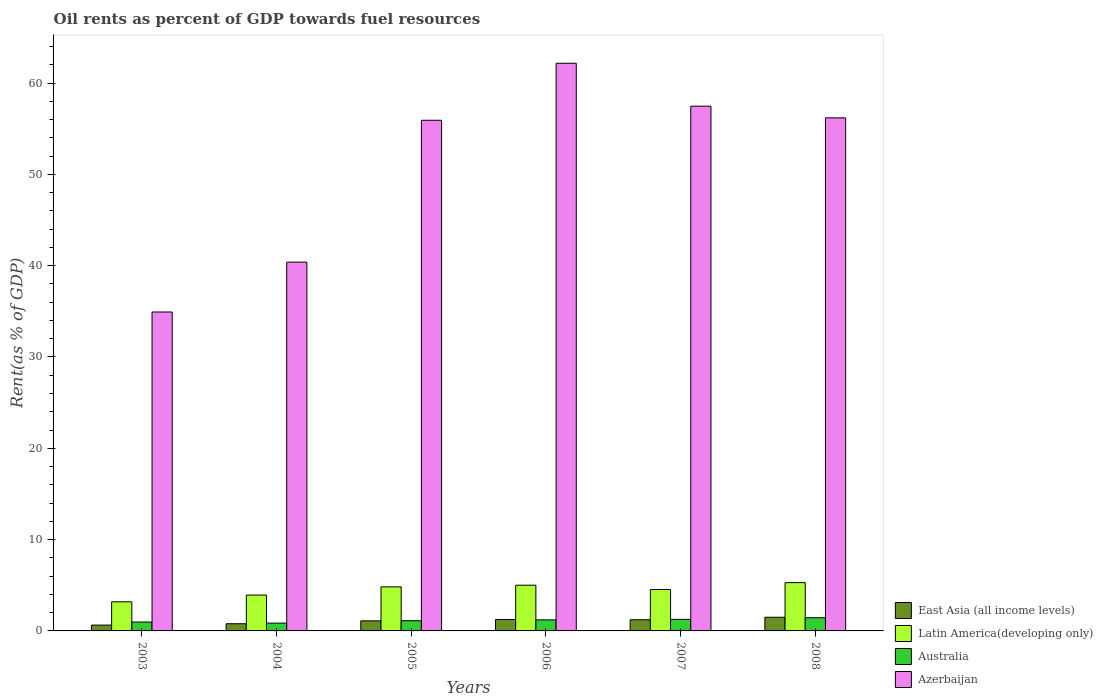How many groups of bars are there?
Provide a short and direct response. 6. Are the number of bars on each tick of the X-axis equal?
Offer a very short reply. Yes. How many bars are there on the 3rd tick from the right?
Keep it short and to the point. 4. In how many cases, is the number of bars for a given year not equal to the number of legend labels?
Provide a succinct answer. 0. What is the oil rent in Azerbaijan in 2005?
Make the answer very short. 55.92. Across all years, what is the maximum oil rent in Australia?
Make the answer very short. 1.45. Across all years, what is the minimum oil rent in Azerbaijan?
Keep it short and to the point. 34.93. In which year was the oil rent in East Asia (all income levels) maximum?
Provide a succinct answer. 2008. What is the total oil rent in East Asia (all income levels) in the graph?
Ensure brevity in your answer.  6.5. What is the difference between the oil rent in East Asia (all income levels) in 2003 and that in 2005?
Offer a very short reply. -0.46. What is the difference between the oil rent in Australia in 2005 and the oil rent in East Asia (all income levels) in 2006?
Provide a succinct answer. -0.13. What is the average oil rent in East Asia (all income levels) per year?
Give a very brief answer. 1.08. In the year 2007, what is the difference between the oil rent in Azerbaijan and oil rent in Latin America(developing only)?
Give a very brief answer. 52.93. What is the ratio of the oil rent in East Asia (all income levels) in 2006 to that in 2008?
Your answer should be very brief. 0.84. What is the difference between the highest and the second highest oil rent in Australia?
Offer a very short reply. 0.18. What is the difference between the highest and the lowest oil rent in Azerbaijan?
Keep it short and to the point. 27.24. Is it the case that in every year, the sum of the oil rent in Latin America(developing only) and oil rent in Australia is greater than the sum of oil rent in East Asia (all income levels) and oil rent in Azerbaijan?
Give a very brief answer. No. What does the 1st bar from the left in 2004 represents?
Provide a short and direct response. East Asia (all income levels). What does the 3rd bar from the right in 2008 represents?
Provide a short and direct response. Latin America(developing only). Does the graph contain grids?
Provide a succinct answer. No. How are the legend labels stacked?
Your response must be concise. Vertical. What is the title of the graph?
Offer a very short reply. Oil rents as percent of GDP towards fuel resources. What is the label or title of the Y-axis?
Ensure brevity in your answer.  Rent(as % of GDP). What is the Rent(as % of GDP) in East Asia (all income levels) in 2003?
Make the answer very short. 0.64. What is the Rent(as % of GDP) in Latin America(developing only) in 2003?
Make the answer very short. 3.19. What is the Rent(as % of GDP) of Australia in 2003?
Provide a succinct answer. 0.97. What is the Rent(as % of GDP) of Azerbaijan in 2003?
Your answer should be compact. 34.93. What is the Rent(as % of GDP) in East Asia (all income levels) in 2004?
Keep it short and to the point. 0.79. What is the Rent(as % of GDP) of Latin America(developing only) in 2004?
Give a very brief answer. 3.93. What is the Rent(as % of GDP) in Australia in 2004?
Make the answer very short. 0.85. What is the Rent(as % of GDP) in Azerbaijan in 2004?
Keep it short and to the point. 40.39. What is the Rent(as % of GDP) in East Asia (all income levels) in 2005?
Offer a terse response. 1.1. What is the Rent(as % of GDP) of Latin America(developing only) in 2005?
Provide a succinct answer. 4.83. What is the Rent(as % of GDP) of Australia in 2005?
Offer a terse response. 1.12. What is the Rent(as % of GDP) of Azerbaijan in 2005?
Your response must be concise. 55.92. What is the Rent(as % of GDP) in East Asia (all income levels) in 2006?
Provide a succinct answer. 1.25. What is the Rent(as % of GDP) of Latin America(developing only) in 2006?
Your answer should be compact. 5.01. What is the Rent(as % of GDP) of Australia in 2006?
Offer a very short reply. 1.21. What is the Rent(as % of GDP) in Azerbaijan in 2006?
Keep it short and to the point. 62.17. What is the Rent(as % of GDP) in East Asia (all income levels) in 2007?
Your response must be concise. 1.22. What is the Rent(as % of GDP) in Latin America(developing only) in 2007?
Offer a very short reply. 4.53. What is the Rent(as % of GDP) in Australia in 2007?
Offer a very short reply. 1.26. What is the Rent(as % of GDP) in Azerbaijan in 2007?
Offer a terse response. 57.47. What is the Rent(as % of GDP) of East Asia (all income levels) in 2008?
Offer a terse response. 1.5. What is the Rent(as % of GDP) in Latin America(developing only) in 2008?
Offer a very short reply. 5.29. What is the Rent(as % of GDP) of Australia in 2008?
Keep it short and to the point. 1.45. What is the Rent(as % of GDP) in Azerbaijan in 2008?
Your answer should be very brief. 56.19. Across all years, what is the maximum Rent(as % of GDP) in East Asia (all income levels)?
Make the answer very short. 1.5. Across all years, what is the maximum Rent(as % of GDP) in Latin America(developing only)?
Offer a terse response. 5.29. Across all years, what is the maximum Rent(as % of GDP) of Australia?
Offer a terse response. 1.45. Across all years, what is the maximum Rent(as % of GDP) of Azerbaijan?
Ensure brevity in your answer.  62.17. Across all years, what is the minimum Rent(as % of GDP) of East Asia (all income levels)?
Ensure brevity in your answer.  0.64. Across all years, what is the minimum Rent(as % of GDP) of Latin America(developing only)?
Your answer should be very brief. 3.19. Across all years, what is the minimum Rent(as % of GDP) in Australia?
Your answer should be very brief. 0.85. Across all years, what is the minimum Rent(as % of GDP) in Azerbaijan?
Offer a terse response. 34.93. What is the total Rent(as % of GDP) in East Asia (all income levels) in the graph?
Give a very brief answer. 6.5. What is the total Rent(as % of GDP) of Latin America(developing only) in the graph?
Your response must be concise. 26.77. What is the total Rent(as % of GDP) of Australia in the graph?
Offer a very short reply. 6.87. What is the total Rent(as % of GDP) in Azerbaijan in the graph?
Keep it short and to the point. 307.05. What is the difference between the Rent(as % of GDP) in East Asia (all income levels) in 2003 and that in 2004?
Give a very brief answer. -0.15. What is the difference between the Rent(as % of GDP) of Latin America(developing only) in 2003 and that in 2004?
Give a very brief answer. -0.74. What is the difference between the Rent(as % of GDP) of Australia in 2003 and that in 2004?
Keep it short and to the point. 0.12. What is the difference between the Rent(as % of GDP) of Azerbaijan in 2003 and that in 2004?
Your answer should be compact. -5.46. What is the difference between the Rent(as % of GDP) of East Asia (all income levels) in 2003 and that in 2005?
Provide a succinct answer. -0.46. What is the difference between the Rent(as % of GDP) of Latin America(developing only) in 2003 and that in 2005?
Your response must be concise. -1.64. What is the difference between the Rent(as % of GDP) in Australia in 2003 and that in 2005?
Ensure brevity in your answer.  -0.15. What is the difference between the Rent(as % of GDP) in Azerbaijan in 2003 and that in 2005?
Provide a succinct answer. -21. What is the difference between the Rent(as % of GDP) in East Asia (all income levels) in 2003 and that in 2006?
Your answer should be compact. -0.61. What is the difference between the Rent(as % of GDP) in Latin America(developing only) in 2003 and that in 2006?
Provide a short and direct response. -1.82. What is the difference between the Rent(as % of GDP) of Australia in 2003 and that in 2006?
Your answer should be compact. -0.24. What is the difference between the Rent(as % of GDP) of Azerbaijan in 2003 and that in 2006?
Keep it short and to the point. -27.24. What is the difference between the Rent(as % of GDP) of East Asia (all income levels) in 2003 and that in 2007?
Offer a very short reply. -0.59. What is the difference between the Rent(as % of GDP) of Latin America(developing only) in 2003 and that in 2007?
Ensure brevity in your answer.  -1.34. What is the difference between the Rent(as % of GDP) in Australia in 2003 and that in 2007?
Your response must be concise. -0.29. What is the difference between the Rent(as % of GDP) in Azerbaijan in 2003 and that in 2007?
Give a very brief answer. -22.54. What is the difference between the Rent(as % of GDP) of East Asia (all income levels) in 2003 and that in 2008?
Offer a very short reply. -0.86. What is the difference between the Rent(as % of GDP) of Latin America(developing only) in 2003 and that in 2008?
Provide a succinct answer. -2.1. What is the difference between the Rent(as % of GDP) of Australia in 2003 and that in 2008?
Keep it short and to the point. -0.47. What is the difference between the Rent(as % of GDP) in Azerbaijan in 2003 and that in 2008?
Offer a very short reply. -21.26. What is the difference between the Rent(as % of GDP) of East Asia (all income levels) in 2004 and that in 2005?
Offer a very short reply. -0.31. What is the difference between the Rent(as % of GDP) of Latin America(developing only) in 2004 and that in 2005?
Your answer should be very brief. -0.9. What is the difference between the Rent(as % of GDP) of Australia in 2004 and that in 2005?
Give a very brief answer. -0.26. What is the difference between the Rent(as % of GDP) of Azerbaijan in 2004 and that in 2005?
Your response must be concise. -15.53. What is the difference between the Rent(as % of GDP) in East Asia (all income levels) in 2004 and that in 2006?
Your answer should be compact. -0.46. What is the difference between the Rent(as % of GDP) of Latin America(developing only) in 2004 and that in 2006?
Offer a very short reply. -1.08. What is the difference between the Rent(as % of GDP) of Australia in 2004 and that in 2006?
Make the answer very short. -0.36. What is the difference between the Rent(as % of GDP) in Azerbaijan in 2004 and that in 2006?
Provide a succinct answer. -21.78. What is the difference between the Rent(as % of GDP) of East Asia (all income levels) in 2004 and that in 2007?
Ensure brevity in your answer.  -0.44. What is the difference between the Rent(as % of GDP) of Latin America(developing only) in 2004 and that in 2007?
Provide a succinct answer. -0.61. What is the difference between the Rent(as % of GDP) of Australia in 2004 and that in 2007?
Keep it short and to the point. -0.41. What is the difference between the Rent(as % of GDP) of Azerbaijan in 2004 and that in 2007?
Ensure brevity in your answer.  -17.08. What is the difference between the Rent(as % of GDP) of East Asia (all income levels) in 2004 and that in 2008?
Offer a terse response. -0.71. What is the difference between the Rent(as % of GDP) in Latin America(developing only) in 2004 and that in 2008?
Provide a succinct answer. -1.36. What is the difference between the Rent(as % of GDP) of Australia in 2004 and that in 2008?
Offer a terse response. -0.59. What is the difference between the Rent(as % of GDP) in Azerbaijan in 2004 and that in 2008?
Your answer should be compact. -15.8. What is the difference between the Rent(as % of GDP) in East Asia (all income levels) in 2005 and that in 2006?
Give a very brief answer. -0.15. What is the difference between the Rent(as % of GDP) in Latin America(developing only) in 2005 and that in 2006?
Ensure brevity in your answer.  -0.18. What is the difference between the Rent(as % of GDP) of Australia in 2005 and that in 2006?
Give a very brief answer. -0.09. What is the difference between the Rent(as % of GDP) in Azerbaijan in 2005 and that in 2006?
Your answer should be very brief. -6.24. What is the difference between the Rent(as % of GDP) of East Asia (all income levels) in 2005 and that in 2007?
Your response must be concise. -0.12. What is the difference between the Rent(as % of GDP) of Latin America(developing only) in 2005 and that in 2007?
Give a very brief answer. 0.29. What is the difference between the Rent(as % of GDP) of Australia in 2005 and that in 2007?
Offer a terse response. -0.15. What is the difference between the Rent(as % of GDP) in Azerbaijan in 2005 and that in 2007?
Your response must be concise. -1.54. What is the difference between the Rent(as % of GDP) in East Asia (all income levels) in 2005 and that in 2008?
Keep it short and to the point. -0.39. What is the difference between the Rent(as % of GDP) of Latin America(developing only) in 2005 and that in 2008?
Offer a very short reply. -0.46. What is the difference between the Rent(as % of GDP) in Australia in 2005 and that in 2008?
Offer a very short reply. -0.33. What is the difference between the Rent(as % of GDP) in Azerbaijan in 2005 and that in 2008?
Keep it short and to the point. -0.26. What is the difference between the Rent(as % of GDP) in East Asia (all income levels) in 2006 and that in 2007?
Your response must be concise. 0.03. What is the difference between the Rent(as % of GDP) in Latin America(developing only) in 2006 and that in 2007?
Your answer should be compact. 0.47. What is the difference between the Rent(as % of GDP) of Australia in 2006 and that in 2007?
Your answer should be compact. -0.05. What is the difference between the Rent(as % of GDP) in Azerbaijan in 2006 and that in 2007?
Your answer should be compact. 4.7. What is the difference between the Rent(as % of GDP) in East Asia (all income levels) in 2006 and that in 2008?
Provide a succinct answer. -0.24. What is the difference between the Rent(as % of GDP) of Latin America(developing only) in 2006 and that in 2008?
Your answer should be very brief. -0.28. What is the difference between the Rent(as % of GDP) of Australia in 2006 and that in 2008?
Provide a short and direct response. -0.23. What is the difference between the Rent(as % of GDP) of Azerbaijan in 2006 and that in 2008?
Offer a very short reply. 5.98. What is the difference between the Rent(as % of GDP) of East Asia (all income levels) in 2007 and that in 2008?
Make the answer very short. -0.27. What is the difference between the Rent(as % of GDP) in Latin America(developing only) in 2007 and that in 2008?
Keep it short and to the point. -0.75. What is the difference between the Rent(as % of GDP) in Australia in 2007 and that in 2008?
Offer a very short reply. -0.18. What is the difference between the Rent(as % of GDP) of Azerbaijan in 2007 and that in 2008?
Keep it short and to the point. 1.28. What is the difference between the Rent(as % of GDP) of East Asia (all income levels) in 2003 and the Rent(as % of GDP) of Latin America(developing only) in 2004?
Give a very brief answer. -3.29. What is the difference between the Rent(as % of GDP) in East Asia (all income levels) in 2003 and the Rent(as % of GDP) in Australia in 2004?
Your answer should be compact. -0.22. What is the difference between the Rent(as % of GDP) in East Asia (all income levels) in 2003 and the Rent(as % of GDP) in Azerbaijan in 2004?
Provide a short and direct response. -39.75. What is the difference between the Rent(as % of GDP) in Latin America(developing only) in 2003 and the Rent(as % of GDP) in Australia in 2004?
Keep it short and to the point. 2.33. What is the difference between the Rent(as % of GDP) in Latin America(developing only) in 2003 and the Rent(as % of GDP) in Azerbaijan in 2004?
Offer a very short reply. -37.2. What is the difference between the Rent(as % of GDP) in Australia in 2003 and the Rent(as % of GDP) in Azerbaijan in 2004?
Keep it short and to the point. -39.41. What is the difference between the Rent(as % of GDP) of East Asia (all income levels) in 2003 and the Rent(as % of GDP) of Latin America(developing only) in 2005?
Your answer should be very brief. -4.19. What is the difference between the Rent(as % of GDP) in East Asia (all income levels) in 2003 and the Rent(as % of GDP) in Australia in 2005?
Ensure brevity in your answer.  -0.48. What is the difference between the Rent(as % of GDP) in East Asia (all income levels) in 2003 and the Rent(as % of GDP) in Azerbaijan in 2005?
Provide a short and direct response. -55.28. What is the difference between the Rent(as % of GDP) in Latin America(developing only) in 2003 and the Rent(as % of GDP) in Australia in 2005?
Ensure brevity in your answer.  2.07. What is the difference between the Rent(as % of GDP) of Latin America(developing only) in 2003 and the Rent(as % of GDP) of Azerbaijan in 2005?
Ensure brevity in your answer.  -52.73. What is the difference between the Rent(as % of GDP) of Australia in 2003 and the Rent(as % of GDP) of Azerbaijan in 2005?
Make the answer very short. -54.95. What is the difference between the Rent(as % of GDP) of East Asia (all income levels) in 2003 and the Rent(as % of GDP) of Latin America(developing only) in 2006?
Your response must be concise. -4.37. What is the difference between the Rent(as % of GDP) in East Asia (all income levels) in 2003 and the Rent(as % of GDP) in Australia in 2006?
Give a very brief answer. -0.57. What is the difference between the Rent(as % of GDP) of East Asia (all income levels) in 2003 and the Rent(as % of GDP) of Azerbaijan in 2006?
Keep it short and to the point. -61.53. What is the difference between the Rent(as % of GDP) in Latin America(developing only) in 2003 and the Rent(as % of GDP) in Australia in 2006?
Your answer should be very brief. 1.98. What is the difference between the Rent(as % of GDP) in Latin America(developing only) in 2003 and the Rent(as % of GDP) in Azerbaijan in 2006?
Your answer should be compact. -58.98. What is the difference between the Rent(as % of GDP) of Australia in 2003 and the Rent(as % of GDP) of Azerbaijan in 2006?
Give a very brief answer. -61.19. What is the difference between the Rent(as % of GDP) of East Asia (all income levels) in 2003 and the Rent(as % of GDP) of Latin America(developing only) in 2007?
Offer a very short reply. -3.9. What is the difference between the Rent(as % of GDP) of East Asia (all income levels) in 2003 and the Rent(as % of GDP) of Australia in 2007?
Give a very brief answer. -0.63. What is the difference between the Rent(as % of GDP) of East Asia (all income levels) in 2003 and the Rent(as % of GDP) of Azerbaijan in 2007?
Give a very brief answer. -56.83. What is the difference between the Rent(as % of GDP) in Latin America(developing only) in 2003 and the Rent(as % of GDP) in Australia in 2007?
Provide a short and direct response. 1.92. What is the difference between the Rent(as % of GDP) in Latin America(developing only) in 2003 and the Rent(as % of GDP) in Azerbaijan in 2007?
Offer a terse response. -54.28. What is the difference between the Rent(as % of GDP) in Australia in 2003 and the Rent(as % of GDP) in Azerbaijan in 2007?
Provide a short and direct response. -56.49. What is the difference between the Rent(as % of GDP) in East Asia (all income levels) in 2003 and the Rent(as % of GDP) in Latin America(developing only) in 2008?
Make the answer very short. -4.65. What is the difference between the Rent(as % of GDP) in East Asia (all income levels) in 2003 and the Rent(as % of GDP) in Australia in 2008?
Your response must be concise. -0.81. What is the difference between the Rent(as % of GDP) of East Asia (all income levels) in 2003 and the Rent(as % of GDP) of Azerbaijan in 2008?
Keep it short and to the point. -55.55. What is the difference between the Rent(as % of GDP) of Latin America(developing only) in 2003 and the Rent(as % of GDP) of Australia in 2008?
Provide a succinct answer. 1.74. What is the difference between the Rent(as % of GDP) of Latin America(developing only) in 2003 and the Rent(as % of GDP) of Azerbaijan in 2008?
Give a very brief answer. -53. What is the difference between the Rent(as % of GDP) of Australia in 2003 and the Rent(as % of GDP) of Azerbaijan in 2008?
Your response must be concise. -55.21. What is the difference between the Rent(as % of GDP) in East Asia (all income levels) in 2004 and the Rent(as % of GDP) in Latin America(developing only) in 2005?
Ensure brevity in your answer.  -4.04. What is the difference between the Rent(as % of GDP) in East Asia (all income levels) in 2004 and the Rent(as % of GDP) in Australia in 2005?
Offer a terse response. -0.33. What is the difference between the Rent(as % of GDP) of East Asia (all income levels) in 2004 and the Rent(as % of GDP) of Azerbaijan in 2005?
Offer a terse response. -55.13. What is the difference between the Rent(as % of GDP) in Latin America(developing only) in 2004 and the Rent(as % of GDP) in Australia in 2005?
Give a very brief answer. 2.81. What is the difference between the Rent(as % of GDP) in Latin America(developing only) in 2004 and the Rent(as % of GDP) in Azerbaijan in 2005?
Your answer should be very brief. -51.99. What is the difference between the Rent(as % of GDP) in Australia in 2004 and the Rent(as % of GDP) in Azerbaijan in 2005?
Your answer should be very brief. -55.07. What is the difference between the Rent(as % of GDP) of East Asia (all income levels) in 2004 and the Rent(as % of GDP) of Latin America(developing only) in 2006?
Keep it short and to the point. -4.22. What is the difference between the Rent(as % of GDP) of East Asia (all income levels) in 2004 and the Rent(as % of GDP) of Australia in 2006?
Provide a succinct answer. -0.42. What is the difference between the Rent(as % of GDP) of East Asia (all income levels) in 2004 and the Rent(as % of GDP) of Azerbaijan in 2006?
Your answer should be very brief. -61.38. What is the difference between the Rent(as % of GDP) of Latin America(developing only) in 2004 and the Rent(as % of GDP) of Australia in 2006?
Give a very brief answer. 2.72. What is the difference between the Rent(as % of GDP) in Latin America(developing only) in 2004 and the Rent(as % of GDP) in Azerbaijan in 2006?
Offer a very short reply. -58.24. What is the difference between the Rent(as % of GDP) of Australia in 2004 and the Rent(as % of GDP) of Azerbaijan in 2006?
Ensure brevity in your answer.  -61.31. What is the difference between the Rent(as % of GDP) in East Asia (all income levels) in 2004 and the Rent(as % of GDP) in Latin America(developing only) in 2007?
Offer a terse response. -3.75. What is the difference between the Rent(as % of GDP) in East Asia (all income levels) in 2004 and the Rent(as % of GDP) in Australia in 2007?
Make the answer very short. -0.48. What is the difference between the Rent(as % of GDP) of East Asia (all income levels) in 2004 and the Rent(as % of GDP) of Azerbaijan in 2007?
Provide a short and direct response. -56.68. What is the difference between the Rent(as % of GDP) in Latin America(developing only) in 2004 and the Rent(as % of GDP) in Australia in 2007?
Your answer should be compact. 2.66. What is the difference between the Rent(as % of GDP) in Latin America(developing only) in 2004 and the Rent(as % of GDP) in Azerbaijan in 2007?
Ensure brevity in your answer.  -53.54. What is the difference between the Rent(as % of GDP) of Australia in 2004 and the Rent(as % of GDP) of Azerbaijan in 2007?
Provide a succinct answer. -56.61. What is the difference between the Rent(as % of GDP) of East Asia (all income levels) in 2004 and the Rent(as % of GDP) of Latin America(developing only) in 2008?
Provide a short and direct response. -4.5. What is the difference between the Rent(as % of GDP) of East Asia (all income levels) in 2004 and the Rent(as % of GDP) of Australia in 2008?
Provide a short and direct response. -0.66. What is the difference between the Rent(as % of GDP) of East Asia (all income levels) in 2004 and the Rent(as % of GDP) of Azerbaijan in 2008?
Your answer should be compact. -55.4. What is the difference between the Rent(as % of GDP) in Latin America(developing only) in 2004 and the Rent(as % of GDP) in Australia in 2008?
Provide a succinct answer. 2.48. What is the difference between the Rent(as % of GDP) of Latin America(developing only) in 2004 and the Rent(as % of GDP) of Azerbaijan in 2008?
Keep it short and to the point. -52.26. What is the difference between the Rent(as % of GDP) in Australia in 2004 and the Rent(as % of GDP) in Azerbaijan in 2008?
Offer a very short reply. -55.33. What is the difference between the Rent(as % of GDP) of East Asia (all income levels) in 2005 and the Rent(as % of GDP) of Latin America(developing only) in 2006?
Offer a terse response. -3.9. What is the difference between the Rent(as % of GDP) in East Asia (all income levels) in 2005 and the Rent(as % of GDP) in Australia in 2006?
Your answer should be compact. -0.11. What is the difference between the Rent(as % of GDP) in East Asia (all income levels) in 2005 and the Rent(as % of GDP) in Azerbaijan in 2006?
Your answer should be compact. -61.06. What is the difference between the Rent(as % of GDP) in Latin America(developing only) in 2005 and the Rent(as % of GDP) in Australia in 2006?
Your answer should be very brief. 3.62. What is the difference between the Rent(as % of GDP) of Latin America(developing only) in 2005 and the Rent(as % of GDP) of Azerbaijan in 2006?
Make the answer very short. -57.34. What is the difference between the Rent(as % of GDP) of Australia in 2005 and the Rent(as % of GDP) of Azerbaijan in 2006?
Your answer should be very brief. -61.05. What is the difference between the Rent(as % of GDP) in East Asia (all income levels) in 2005 and the Rent(as % of GDP) in Latin America(developing only) in 2007?
Ensure brevity in your answer.  -3.43. What is the difference between the Rent(as % of GDP) of East Asia (all income levels) in 2005 and the Rent(as % of GDP) of Australia in 2007?
Your answer should be compact. -0.16. What is the difference between the Rent(as % of GDP) in East Asia (all income levels) in 2005 and the Rent(as % of GDP) in Azerbaijan in 2007?
Offer a very short reply. -56.36. What is the difference between the Rent(as % of GDP) of Latin America(developing only) in 2005 and the Rent(as % of GDP) of Australia in 2007?
Ensure brevity in your answer.  3.56. What is the difference between the Rent(as % of GDP) of Latin America(developing only) in 2005 and the Rent(as % of GDP) of Azerbaijan in 2007?
Give a very brief answer. -52.64. What is the difference between the Rent(as % of GDP) of Australia in 2005 and the Rent(as % of GDP) of Azerbaijan in 2007?
Offer a very short reply. -56.35. What is the difference between the Rent(as % of GDP) in East Asia (all income levels) in 2005 and the Rent(as % of GDP) in Latin America(developing only) in 2008?
Make the answer very short. -4.19. What is the difference between the Rent(as % of GDP) of East Asia (all income levels) in 2005 and the Rent(as % of GDP) of Australia in 2008?
Your response must be concise. -0.34. What is the difference between the Rent(as % of GDP) in East Asia (all income levels) in 2005 and the Rent(as % of GDP) in Azerbaijan in 2008?
Your answer should be very brief. -55.08. What is the difference between the Rent(as % of GDP) in Latin America(developing only) in 2005 and the Rent(as % of GDP) in Australia in 2008?
Offer a terse response. 3.38. What is the difference between the Rent(as % of GDP) of Latin America(developing only) in 2005 and the Rent(as % of GDP) of Azerbaijan in 2008?
Give a very brief answer. -51.36. What is the difference between the Rent(as % of GDP) in Australia in 2005 and the Rent(as % of GDP) in Azerbaijan in 2008?
Provide a short and direct response. -55.07. What is the difference between the Rent(as % of GDP) of East Asia (all income levels) in 2006 and the Rent(as % of GDP) of Latin America(developing only) in 2007?
Your answer should be compact. -3.28. What is the difference between the Rent(as % of GDP) in East Asia (all income levels) in 2006 and the Rent(as % of GDP) in Australia in 2007?
Provide a short and direct response. -0.01. What is the difference between the Rent(as % of GDP) in East Asia (all income levels) in 2006 and the Rent(as % of GDP) in Azerbaijan in 2007?
Your answer should be very brief. -56.21. What is the difference between the Rent(as % of GDP) of Latin America(developing only) in 2006 and the Rent(as % of GDP) of Australia in 2007?
Make the answer very short. 3.74. What is the difference between the Rent(as % of GDP) in Latin America(developing only) in 2006 and the Rent(as % of GDP) in Azerbaijan in 2007?
Provide a succinct answer. -52.46. What is the difference between the Rent(as % of GDP) of Australia in 2006 and the Rent(as % of GDP) of Azerbaijan in 2007?
Offer a terse response. -56.26. What is the difference between the Rent(as % of GDP) of East Asia (all income levels) in 2006 and the Rent(as % of GDP) of Latin America(developing only) in 2008?
Your answer should be compact. -4.04. What is the difference between the Rent(as % of GDP) in East Asia (all income levels) in 2006 and the Rent(as % of GDP) in Australia in 2008?
Your response must be concise. -0.19. What is the difference between the Rent(as % of GDP) in East Asia (all income levels) in 2006 and the Rent(as % of GDP) in Azerbaijan in 2008?
Your answer should be very brief. -54.93. What is the difference between the Rent(as % of GDP) of Latin America(developing only) in 2006 and the Rent(as % of GDP) of Australia in 2008?
Offer a very short reply. 3.56. What is the difference between the Rent(as % of GDP) in Latin America(developing only) in 2006 and the Rent(as % of GDP) in Azerbaijan in 2008?
Offer a terse response. -51.18. What is the difference between the Rent(as % of GDP) of Australia in 2006 and the Rent(as % of GDP) of Azerbaijan in 2008?
Provide a short and direct response. -54.98. What is the difference between the Rent(as % of GDP) in East Asia (all income levels) in 2007 and the Rent(as % of GDP) in Latin America(developing only) in 2008?
Ensure brevity in your answer.  -4.06. What is the difference between the Rent(as % of GDP) of East Asia (all income levels) in 2007 and the Rent(as % of GDP) of Australia in 2008?
Offer a very short reply. -0.22. What is the difference between the Rent(as % of GDP) of East Asia (all income levels) in 2007 and the Rent(as % of GDP) of Azerbaijan in 2008?
Provide a succinct answer. -54.96. What is the difference between the Rent(as % of GDP) of Latin America(developing only) in 2007 and the Rent(as % of GDP) of Australia in 2008?
Give a very brief answer. 3.09. What is the difference between the Rent(as % of GDP) of Latin America(developing only) in 2007 and the Rent(as % of GDP) of Azerbaijan in 2008?
Provide a short and direct response. -51.65. What is the difference between the Rent(as % of GDP) of Australia in 2007 and the Rent(as % of GDP) of Azerbaijan in 2008?
Provide a short and direct response. -54.92. What is the average Rent(as % of GDP) of East Asia (all income levels) per year?
Give a very brief answer. 1.08. What is the average Rent(as % of GDP) in Latin America(developing only) per year?
Give a very brief answer. 4.46. What is the average Rent(as % of GDP) in Australia per year?
Provide a short and direct response. 1.14. What is the average Rent(as % of GDP) in Azerbaijan per year?
Make the answer very short. 51.18. In the year 2003, what is the difference between the Rent(as % of GDP) in East Asia (all income levels) and Rent(as % of GDP) in Latin America(developing only)?
Your response must be concise. -2.55. In the year 2003, what is the difference between the Rent(as % of GDP) in East Asia (all income levels) and Rent(as % of GDP) in Australia?
Offer a terse response. -0.34. In the year 2003, what is the difference between the Rent(as % of GDP) in East Asia (all income levels) and Rent(as % of GDP) in Azerbaijan?
Make the answer very short. -34.29. In the year 2003, what is the difference between the Rent(as % of GDP) in Latin America(developing only) and Rent(as % of GDP) in Australia?
Offer a very short reply. 2.22. In the year 2003, what is the difference between the Rent(as % of GDP) of Latin America(developing only) and Rent(as % of GDP) of Azerbaijan?
Your answer should be compact. -31.74. In the year 2003, what is the difference between the Rent(as % of GDP) of Australia and Rent(as % of GDP) of Azerbaijan?
Your response must be concise. -33.95. In the year 2004, what is the difference between the Rent(as % of GDP) of East Asia (all income levels) and Rent(as % of GDP) of Latin America(developing only)?
Give a very brief answer. -3.14. In the year 2004, what is the difference between the Rent(as % of GDP) in East Asia (all income levels) and Rent(as % of GDP) in Australia?
Your answer should be compact. -0.07. In the year 2004, what is the difference between the Rent(as % of GDP) in East Asia (all income levels) and Rent(as % of GDP) in Azerbaijan?
Your answer should be compact. -39.6. In the year 2004, what is the difference between the Rent(as % of GDP) in Latin America(developing only) and Rent(as % of GDP) in Australia?
Give a very brief answer. 3.07. In the year 2004, what is the difference between the Rent(as % of GDP) in Latin America(developing only) and Rent(as % of GDP) in Azerbaijan?
Your answer should be compact. -36.46. In the year 2004, what is the difference between the Rent(as % of GDP) in Australia and Rent(as % of GDP) in Azerbaijan?
Keep it short and to the point. -39.53. In the year 2005, what is the difference between the Rent(as % of GDP) in East Asia (all income levels) and Rent(as % of GDP) in Latin America(developing only)?
Make the answer very short. -3.72. In the year 2005, what is the difference between the Rent(as % of GDP) in East Asia (all income levels) and Rent(as % of GDP) in Australia?
Your answer should be very brief. -0.02. In the year 2005, what is the difference between the Rent(as % of GDP) in East Asia (all income levels) and Rent(as % of GDP) in Azerbaijan?
Ensure brevity in your answer.  -54.82. In the year 2005, what is the difference between the Rent(as % of GDP) in Latin America(developing only) and Rent(as % of GDP) in Australia?
Provide a succinct answer. 3.71. In the year 2005, what is the difference between the Rent(as % of GDP) of Latin America(developing only) and Rent(as % of GDP) of Azerbaijan?
Your response must be concise. -51.1. In the year 2005, what is the difference between the Rent(as % of GDP) of Australia and Rent(as % of GDP) of Azerbaijan?
Ensure brevity in your answer.  -54.8. In the year 2006, what is the difference between the Rent(as % of GDP) in East Asia (all income levels) and Rent(as % of GDP) in Latin America(developing only)?
Ensure brevity in your answer.  -3.76. In the year 2006, what is the difference between the Rent(as % of GDP) of East Asia (all income levels) and Rent(as % of GDP) of Australia?
Keep it short and to the point. 0.04. In the year 2006, what is the difference between the Rent(as % of GDP) in East Asia (all income levels) and Rent(as % of GDP) in Azerbaijan?
Your answer should be very brief. -60.91. In the year 2006, what is the difference between the Rent(as % of GDP) in Latin America(developing only) and Rent(as % of GDP) in Australia?
Offer a terse response. 3.8. In the year 2006, what is the difference between the Rent(as % of GDP) in Latin America(developing only) and Rent(as % of GDP) in Azerbaijan?
Give a very brief answer. -57.16. In the year 2006, what is the difference between the Rent(as % of GDP) in Australia and Rent(as % of GDP) in Azerbaijan?
Keep it short and to the point. -60.96. In the year 2007, what is the difference between the Rent(as % of GDP) of East Asia (all income levels) and Rent(as % of GDP) of Latin America(developing only)?
Offer a very short reply. -3.31. In the year 2007, what is the difference between the Rent(as % of GDP) of East Asia (all income levels) and Rent(as % of GDP) of Australia?
Keep it short and to the point. -0.04. In the year 2007, what is the difference between the Rent(as % of GDP) in East Asia (all income levels) and Rent(as % of GDP) in Azerbaijan?
Offer a terse response. -56.24. In the year 2007, what is the difference between the Rent(as % of GDP) in Latin America(developing only) and Rent(as % of GDP) in Australia?
Give a very brief answer. 3.27. In the year 2007, what is the difference between the Rent(as % of GDP) of Latin America(developing only) and Rent(as % of GDP) of Azerbaijan?
Make the answer very short. -52.93. In the year 2007, what is the difference between the Rent(as % of GDP) in Australia and Rent(as % of GDP) in Azerbaijan?
Your answer should be compact. -56.2. In the year 2008, what is the difference between the Rent(as % of GDP) of East Asia (all income levels) and Rent(as % of GDP) of Latin America(developing only)?
Keep it short and to the point. -3.79. In the year 2008, what is the difference between the Rent(as % of GDP) in East Asia (all income levels) and Rent(as % of GDP) in Australia?
Provide a succinct answer. 0.05. In the year 2008, what is the difference between the Rent(as % of GDP) in East Asia (all income levels) and Rent(as % of GDP) in Azerbaijan?
Provide a short and direct response. -54.69. In the year 2008, what is the difference between the Rent(as % of GDP) of Latin America(developing only) and Rent(as % of GDP) of Australia?
Make the answer very short. 3.84. In the year 2008, what is the difference between the Rent(as % of GDP) in Latin America(developing only) and Rent(as % of GDP) in Azerbaijan?
Ensure brevity in your answer.  -50.9. In the year 2008, what is the difference between the Rent(as % of GDP) in Australia and Rent(as % of GDP) in Azerbaijan?
Provide a short and direct response. -54.74. What is the ratio of the Rent(as % of GDP) in East Asia (all income levels) in 2003 to that in 2004?
Provide a short and direct response. 0.81. What is the ratio of the Rent(as % of GDP) in Latin America(developing only) in 2003 to that in 2004?
Provide a succinct answer. 0.81. What is the ratio of the Rent(as % of GDP) of Australia in 2003 to that in 2004?
Provide a short and direct response. 1.14. What is the ratio of the Rent(as % of GDP) of Azerbaijan in 2003 to that in 2004?
Your answer should be compact. 0.86. What is the ratio of the Rent(as % of GDP) in East Asia (all income levels) in 2003 to that in 2005?
Your answer should be very brief. 0.58. What is the ratio of the Rent(as % of GDP) in Latin America(developing only) in 2003 to that in 2005?
Offer a very short reply. 0.66. What is the ratio of the Rent(as % of GDP) of Australia in 2003 to that in 2005?
Ensure brevity in your answer.  0.87. What is the ratio of the Rent(as % of GDP) in Azerbaijan in 2003 to that in 2005?
Provide a short and direct response. 0.62. What is the ratio of the Rent(as % of GDP) of East Asia (all income levels) in 2003 to that in 2006?
Make the answer very short. 0.51. What is the ratio of the Rent(as % of GDP) of Latin America(developing only) in 2003 to that in 2006?
Provide a succinct answer. 0.64. What is the ratio of the Rent(as % of GDP) in Australia in 2003 to that in 2006?
Give a very brief answer. 0.8. What is the ratio of the Rent(as % of GDP) of Azerbaijan in 2003 to that in 2006?
Provide a short and direct response. 0.56. What is the ratio of the Rent(as % of GDP) in East Asia (all income levels) in 2003 to that in 2007?
Offer a terse response. 0.52. What is the ratio of the Rent(as % of GDP) of Latin America(developing only) in 2003 to that in 2007?
Give a very brief answer. 0.7. What is the ratio of the Rent(as % of GDP) of Australia in 2003 to that in 2007?
Your answer should be very brief. 0.77. What is the ratio of the Rent(as % of GDP) in Azerbaijan in 2003 to that in 2007?
Ensure brevity in your answer.  0.61. What is the ratio of the Rent(as % of GDP) of East Asia (all income levels) in 2003 to that in 2008?
Make the answer very short. 0.43. What is the ratio of the Rent(as % of GDP) in Latin America(developing only) in 2003 to that in 2008?
Offer a very short reply. 0.6. What is the ratio of the Rent(as % of GDP) of Australia in 2003 to that in 2008?
Keep it short and to the point. 0.67. What is the ratio of the Rent(as % of GDP) in Azerbaijan in 2003 to that in 2008?
Offer a terse response. 0.62. What is the ratio of the Rent(as % of GDP) in East Asia (all income levels) in 2004 to that in 2005?
Offer a terse response. 0.71. What is the ratio of the Rent(as % of GDP) of Latin America(developing only) in 2004 to that in 2005?
Keep it short and to the point. 0.81. What is the ratio of the Rent(as % of GDP) in Australia in 2004 to that in 2005?
Ensure brevity in your answer.  0.76. What is the ratio of the Rent(as % of GDP) of Azerbaijan in 2004 to that in 2005?
Offer a very short reply. 0.72. What is the ratio of the Rent(as % of GDP) in East Asia (all income levels) in 2004 to that in 2006?
Keep it short and to the point. 0.63. What is the ratio of the Rent(as % of GDP) of Latin America(developing only) in 2004 to that in 2006?
Keep it short and to the point. 0.78. What is the ratio of the Rent(as % of GDP) in Australia in 2004 to that in 2006?
Ensure brevity in your answer.  0.71. What is the ratio of the Rent(as % of GDP) of Azerbaijan in 2004 to that in 2006?
Provide a succinct answer. 0.65. What is the ratio of the Rent(as % of GDP) of East Asia (all income levels) in 2004 to that in 2007?
Ensure brevity in your answer.  0.64. What is the ratio of the Rent(as % of GDP) of Latin America(developing only) in 2004 to that in 2007?
Make the answer very short. 0.87. What is the ratio of the Rent(as % of GDP) in Australia in 2004 to that in 2007?
Make the answer very short. 0.68. What is the ratio of the Rent(as % of GDP) in Azerbaijan in 2004 to that in 2007?
Provide a short and direct response. 0.7. What is the ratio of the Rent(as % of GDP) of East Asia (all income levels) in 2004 to that in 2008?
Make the answer very short. 0.53. What is the ratio of the Rent(as % of GDP) of Latin America(developing only) in 2004 to that in 2008?
Ensure brevity in your answer.  0.74. What is the ratio of the Rent(as % of GDP) in Australia in 2004 to that in 2008?
Your answer should be very brief. 0.59. What is the ratio of the Rent(as % of GDP) of Azerbaijan in 2004 to that in 2008?
Give a very brief answer. 0.72. What is the ratio of the Rent(as % of GDP) of East Asia (all income levels) in 2005 to that in 2006?
Offer a terse response. 0.88. What is the ratio of the Rent(as % of GDP) of Latin America(developing only) in 2005 to that in 2006?
Keep it short and to the point. 0.96. What is the ratio of the Rent(as % of GDP) in Australia in 2005 to that in 2006?
Your response must be concise. 0.92. What is the ratio of the Rent(as % of GDP) in Azerbaijan in 2005 to that in 2006?
Keep it short and to the point. 0.9. What is the ratio of the Rent(as % of GDP) of Latin America(developing only) in 2005 to that in 2007?
Give a very brief answer. 1.06. What is the ratio of the Rent(as % of GDP) of Australia in 2005 to that in 2007?
Keep it short and to the point. 0.88. What is the ratio of the Rent(as % of GDP) in Azerbaijan in 2005 to that in 2007?
Keep it short and to the point. 0.97. What is the ratio of the Rent(as % of GDP) of East Asia (all income levels) in 2005 to that in 2008?
Provide a short and direct response. 0.74. What is the ratio of the Rent(as % of GDP) of Latin America(developing only) in 2005 to that in 2008?
Your answer should be very brief. 0.91. What is the ratio of the Rent(as % of GDP) in Australia in 2005 to that in 2008?
Your answer should be very brief. 0.77. What is the ratio of the Rent(as % of GDP) in East Asia (all income levels) in 2006 to that in 2007?
Your answer should be compact. 1.02. What is the ratio of the Rent(as % of GDP) in Latin America(developing only) in 2006 to that in 2007?
Your answer should be compact. 1.1. What is the ratio of the Rent(as % of GDP) in Australia in 2006 to that in 2007?
Your answer should be very brief. 0.96. What is the ratio of the Rent(as % of GDP) in Azerbaijan in 2006 to that in 2007?
Give a very brief answer. 1.08. What is the ratio of the Rent(as % of GDP) in East Asia (all income levels) in 2006 to that in 2008?
Ensure brevity in your answer.  0.84. What is the ratio of the Rent(as % of GDP) of Latin America(developing only) in 2006 to that in 2008?
Provide a succinct answer. 0.95. What is the ratio of the Rent(as % of GDP) in Australia in 2006 to that in 2008?
Offer a terse response. 0.84. What is the ratio of the Rent(as % of GDP) of Azerbaijan in 2006 to that in 2008?
Provide a short and direct response. 1.11. What is the ratio of the Rent(as % of GDP) of East Asia (all income levels) in 2007 to that in 2008?
Offer a terse response. 0.82. What is the ratio of the Rent(as % of GDP) of Latin America(developing only) in 2007 to that in 2008?
Offer a very short reply. 0.86. What is the ratio of the Rent(as % of GDP) of Australia in 2007 to that in 2008?
Your answer should be very brief. 0.88. What is the ratio of the Rent(as % of GDP) of Azerbaijan in 2007 to that in 2008?
Provide a short and direct response. 1.02. What is the difference between the highest and the second highest Rent(as % of GDP) in East Asia (all income levels)?
Your response must be concise. 0.24. What is the difference between the highest and the second highest Rent(as % of GDP) in Latin America(developing only)?
Provide a short and direct response. 0.28. What is the difference between the highest and the second highest Rent(as % of GDP) in Australia?
Your answer should be very brief. 0.18. What is the difference between the highest and the second highest Rent(as % of GDP) in Azerbaijan?
Provide a succinct answer. 4.7. What is the difference between the highest and the lowest Rent(as % of GDP) of East Asia (all income levels)?
Your response must be concise. 0.86. What is the difference between the highest and the lowest Rent(as % of GDP) of Latin America(developing only)?
Offer a very short reply. 2.1. What is the difference between the highest and the lowest Rent(as % of GDP) in Australia?
Provide a short and direct response. 0.59. What is the difference between the highest and the lowest Rent(as % of GDP) in Azerbaijan?
Ensure brevity in your answer.  27.24. 